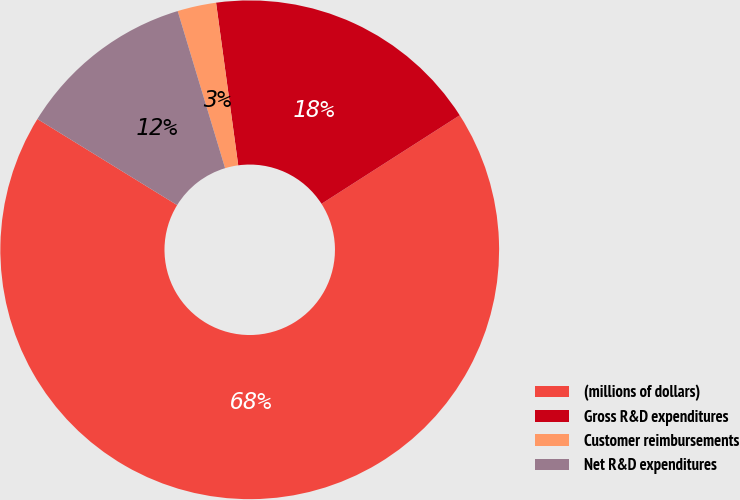<chart> <loc_0><loc_0><loc_500><loc_500><pie_chart><fcel>(millions of dollars)<fcel>Gross R&D expenditures<fcel>Customer reimbursements<fcel>Net R&D expenditures<nl><fcel>67.85%<fcel>18.09%<fcel>2.51%<fcel>11.55%<nl></chart> 